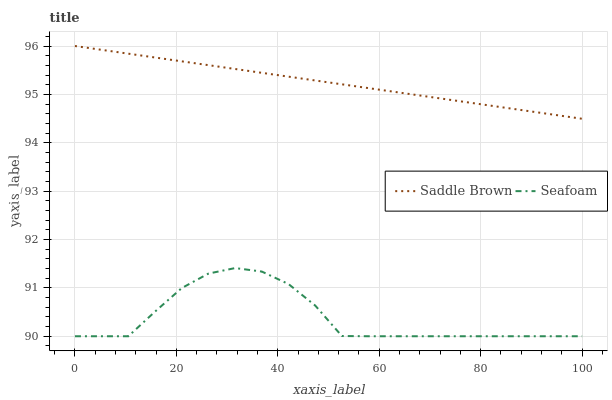Does Seafoam have the minimum area under the curve?
Answer yes or no. Yes. Does Saddle Brown have the maximum area under the curve?
Answer yes or no. Yes. Does Seafoam have the maximum area under the curve?
Answer yes or no. No. Is Saddle Brown the smoothest?
Answer yes or no. Yes. Is Seafoam the roughest?
Answer yes or no. Yes. Is Seafoam the smoothest?
Answer yes or no. No. Does Seafoam have the lowest value?
Answer yes or no. Yes. Does Saddle Brown have the highest value?
Answer yes or no. Yes. Does Seafoam have the highest value?
Answer yes or no. No. Is Seafoam less than Saddle Brown?
Answer yes or no. Yes. Is Saddle Brown greater than Seafoam?
Answer yes or no. Yes. Does Seafoam intersect Saddle Brown?
Answer yes or no. No. 